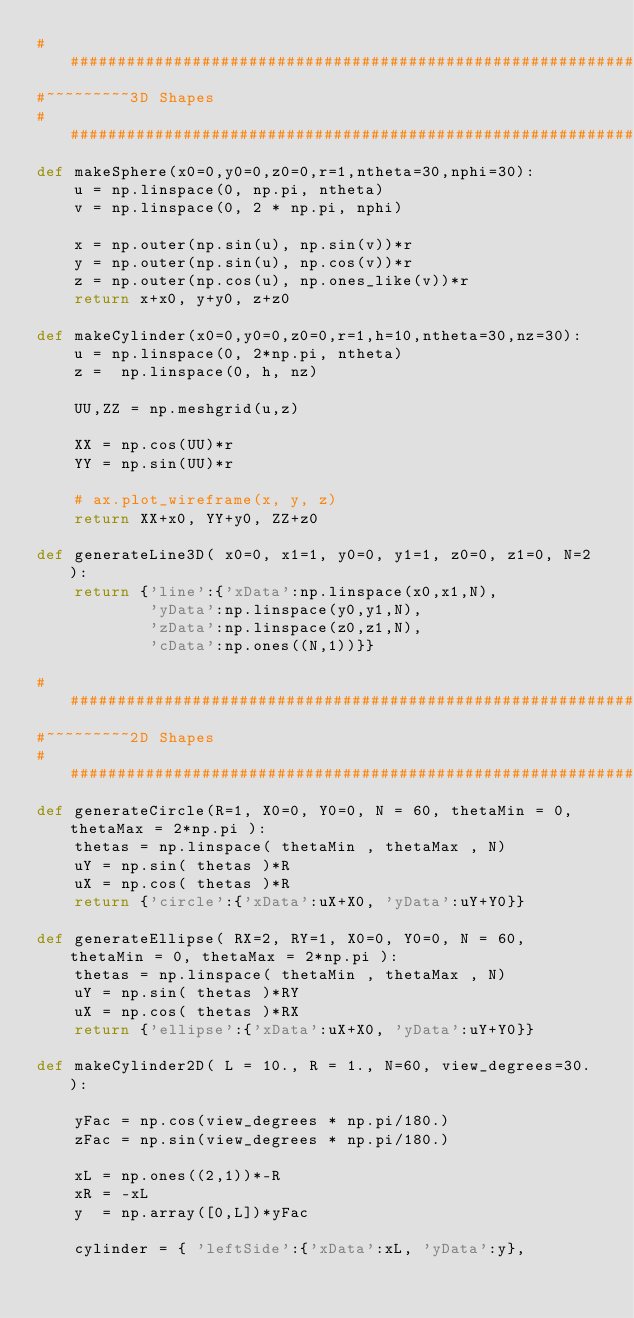<code> <loc_0><loc_0><loc_500><loc_500><_Python_>################################################################################
#~~~~~~~~~3D Shapes
################################################################################
def makeSphere(x0=0,y0=0,z0=0,r=1,ntheta=30,nphi=30):
    u = np.linspace(0, np.pi, ntheta)
    v = np.linspace(0, 2 * np.pi, nphi)

    x = np.outer(np.sin(u), np.sin(v))*r
    y = np.outer(np.sin(u), np.cos(v))*r
    z = np.outer(np.cos(u), np.ones_like(v))*r
    return x+x0, y+y0, z+z0

def makeCylinder(x0=0,y0=0,z0=0,r=1,h=10,ntheta=30,nz=30):
    u = np.linspace(0, 2*np.pi, ntheta)
    z =  np.linspace(0, h, nz)

    UU,ZZ = np.meshgrid(u,z)

    XX = np.cos(UU)*r
    YY = np.sin(UU)*r

    # ax.plot_wireframe(x, y, z)
    return XX+x0, YY+y0, ZZ+z0

def generateLine3D( x0=0, x1=1, y0=0, y1=1, z0=0, z1=0, N=2 ):
    return {'line':{'xData':np.linspace(x0,x1,N),
            'yData':np.linspace(y0,y1,N),
            'zData':np.linspace(z0,z1,N),
            'cData':np.ones((N,1))}}

################################################################################
#~~~~~~~~~2D Shapes
################################################################################
def generateCircle(R=1, X0=0, Y0=0, N = 60, thetaMin = 0, thetaMax = 2*np.pi ):
    thetas = np.linspace( thetaMin , thetaMax , N)
    uY = np.sin( thetas )*R
    uX = np.cos( thetas )*R
    return {'circle':{'xData':uX+X0, 'yData':uY+Y0}}

def generateEllipse( RX=2, RY=1, X0=0, Y0=0, N = 60, thetaMin = 0, thetaMax = 2*np.pi ):
    thetas = np.linspace( thetaMin , thetaMax , N)
    uY = np.sin( thetas )*RY
    uX = np.cos( thetas )*RX
    return {'ellipse':{'xData':uX+X0, 'yData':uY+Y0}}

def makeCylinder2D( L = 10., R = 1., N=60, view_degrees=30. ):

    yFac = np.cos(view_degrees * np.pi/180.)
    zFac = np.sin(view_degrees * np.pi/180.)

    xL = np.ones((2,1))*-R
    xR = -xL
    y  = np.array([0,L])*yFac

    cylinder = { 'leftSide':{'xData':xL, 'yData':y},</code> 